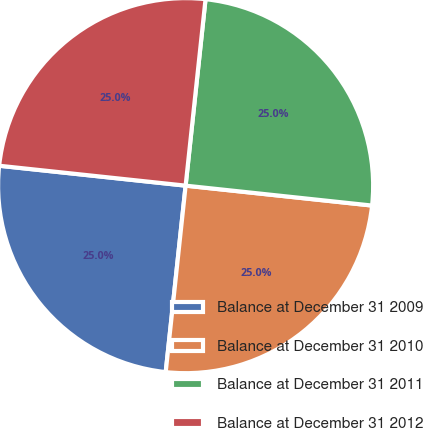<chart> <loc_0><loc_0><loc_500><loc_500><pie_chart><fcel>Balance at December 31 2009<fcel>Balance at December 31 2010<fcel>Balance at December 31 2011<fcel>Balance at December 31 2012<nl><fcel>25.0%<fcel>25.0%<fcel>25.0%<fcel>25.0%<nl></chart> 